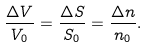<formula> <loc_0><loc_0><loc_500><loc_500>\frac { \Delta V } { V _ { 0 } } = \frac { \Delta S } { S _ { 0 } } = \frac { \Delta n } { n _ { 0 } } .</formula> 